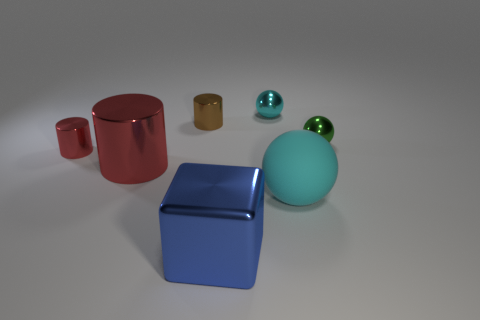Are there any other things that are the same material as the big cyan sphere?
Keep it short and to the point. No. What number of big things are blue blocks or red metallic objects?
Your response must be concise. 2. How many objects are objects right of the cyan rubber object or large cyan rubber spheres?
Offer a terse response. 2. How many other objects are the same shape as the big cyan thing?
Offer a very short reply. 2. What number of purple things are either metallic spheres or matte cylinders?
Offer a terse response. 0. There is a large block that is the same material as the brown cylinder; what color is it?
Provide a short and direct response. Blue. Are the big object behind the rubber sphere and the cyan thing that is in front of the large red thing made of the same material?
Provide a short and direct response. No. There is a metallic ball that is the same color as the rubber ball; what is its size?
Give a very brief answer. Small. There is a small cylinder that is on the left side of the brown shiny object; what is its material?
Provide a succinct answer. Metal. Do the big thing that is left of the small brown object and the tiny metallic thing on the left side of the brown cylinder have the same shape?
Keep it short and to the point. Yes. 